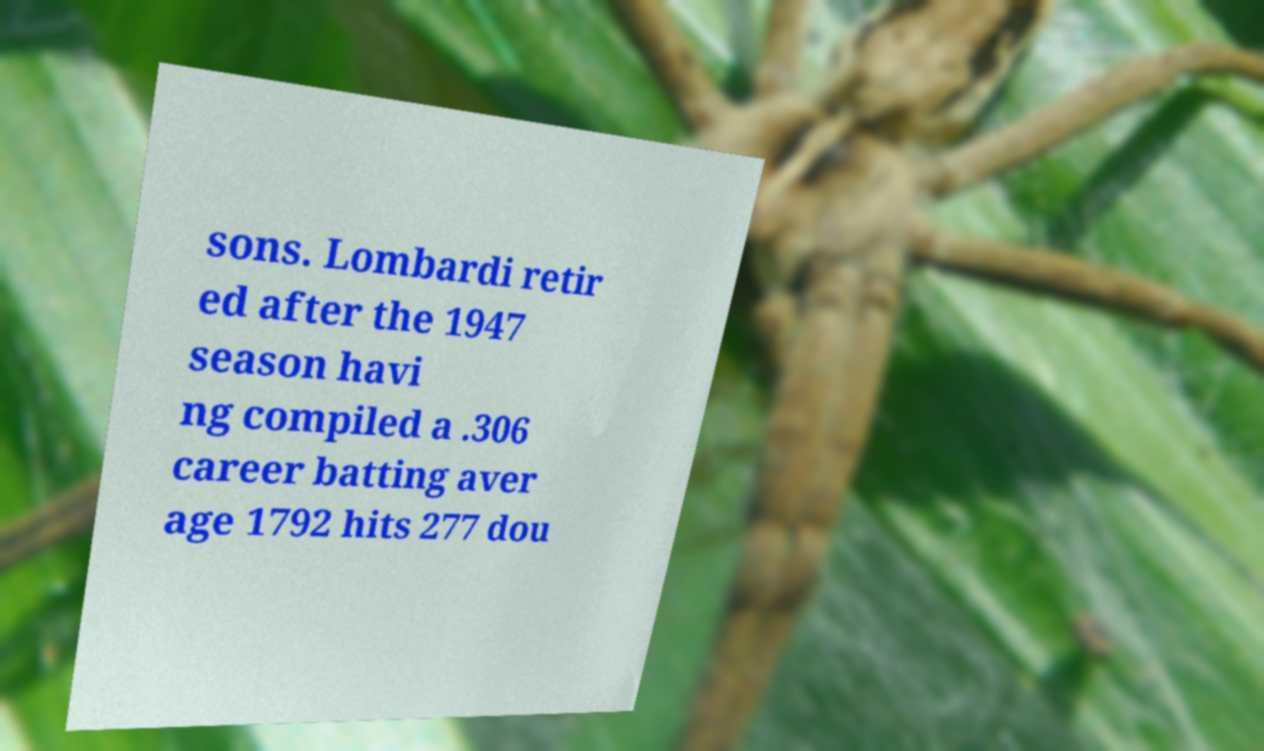Could you extract and type out the text from this image? sons. Lombardi retir ed after the 1947 season havi ng compiled a .306 career batting aver age 1792 hits 277 dou 